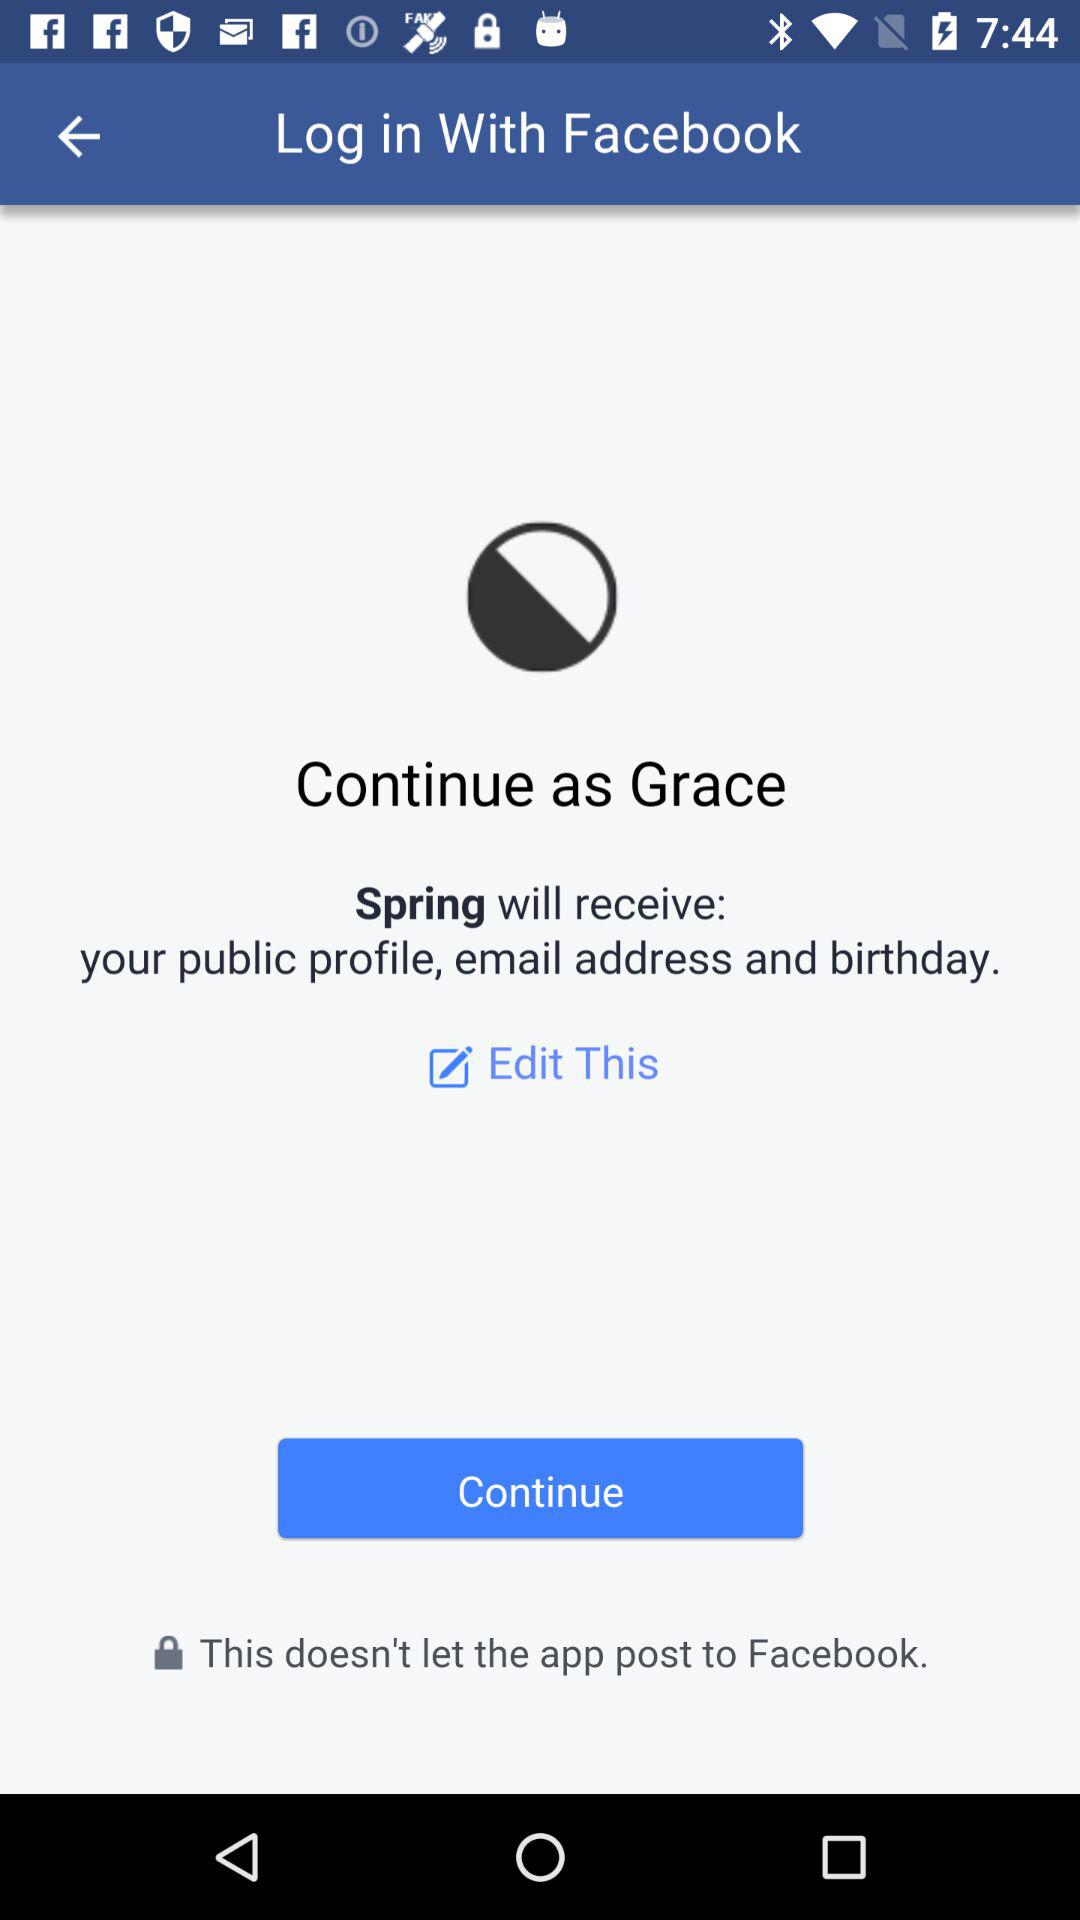Through what application is the person logging in? The person is logging in through "Facebook". 